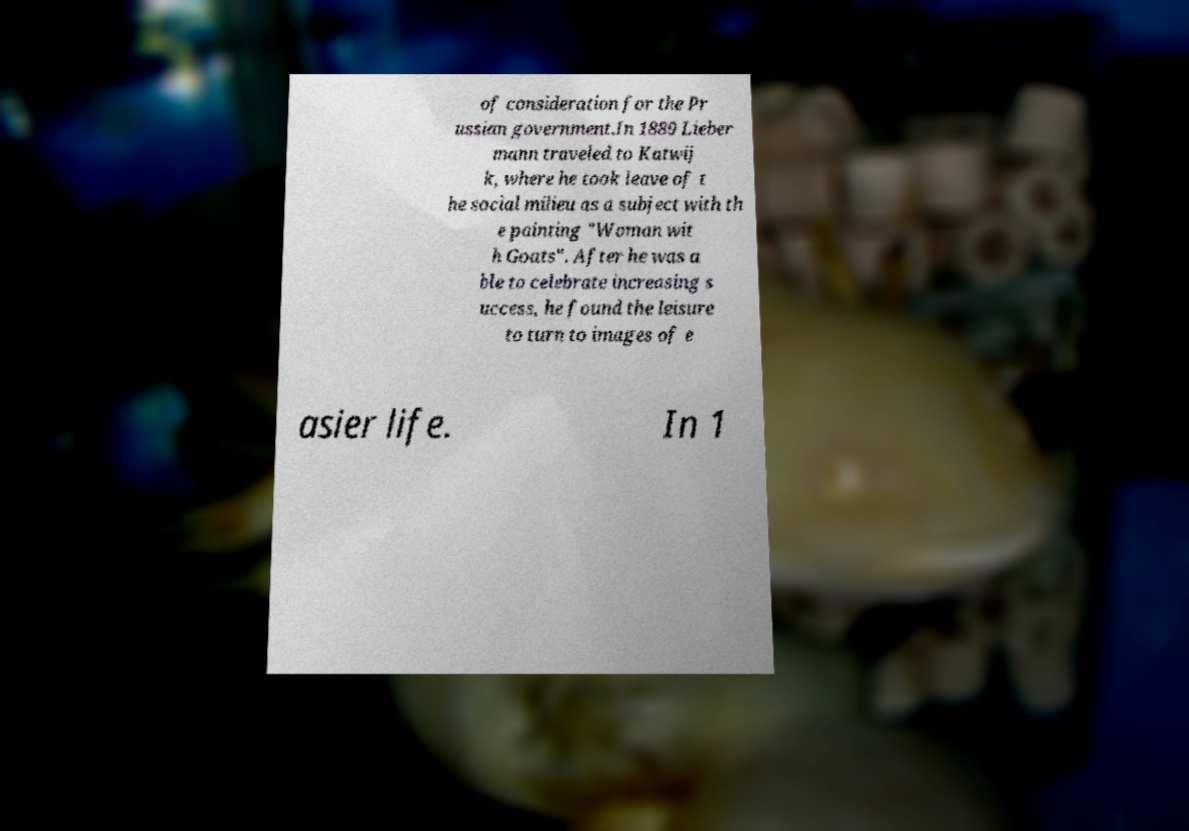There's text embedded in this image that I need extracted. Can you transcribe it verbatim? of consideration for the Pr ussian government.In 1889 Lieber mann traveled to Katwij k, where he took leave of t he social milieu as a subject with th e painting "Woman wit h Goats". After he was a ble to celebrate increasing s uccess, he found the leisure to turn to images of e asier life. In 1 